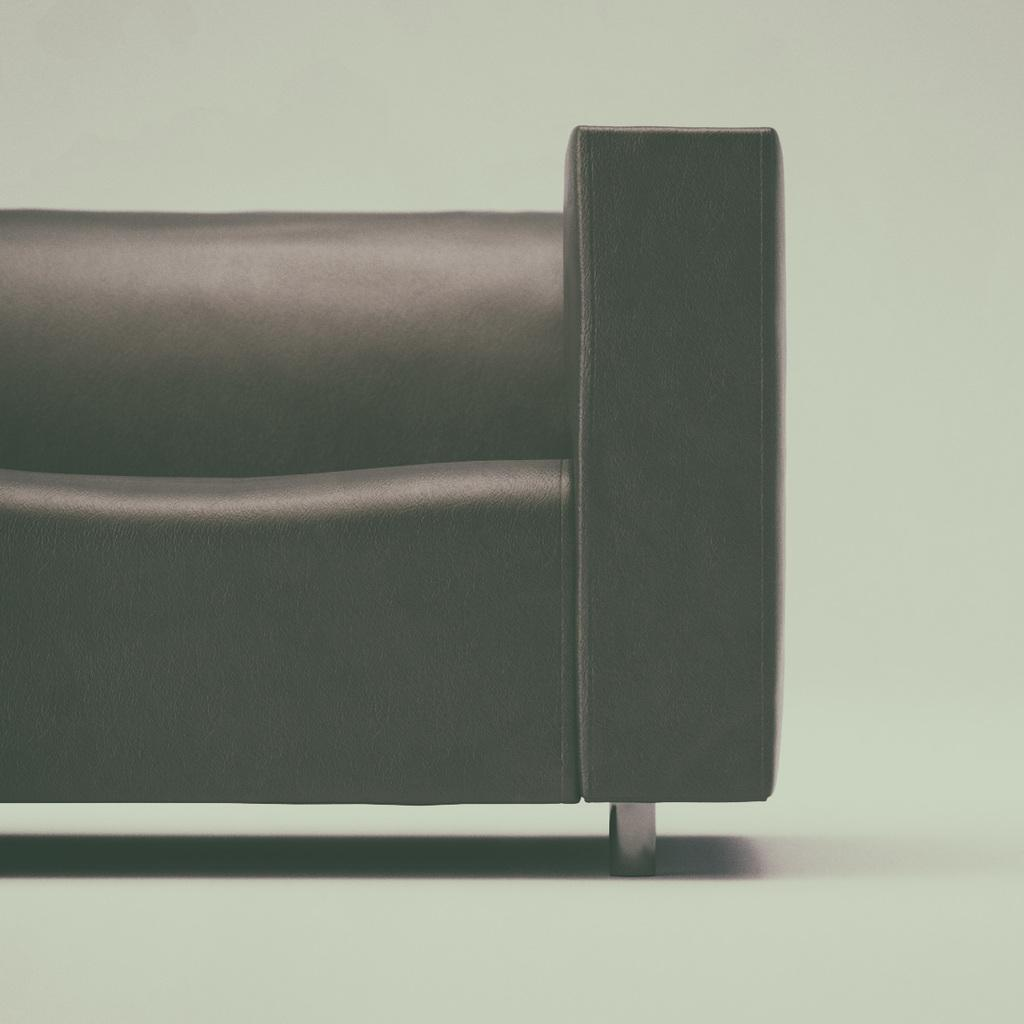What color is the sofa in the image? The sofa in the image is black. Where is the sofa located in the image? The sofa is on the floor. How many books are stacked on the sofa in the image? There are no books visible in the image; it only shows a black sofa on the floor. 